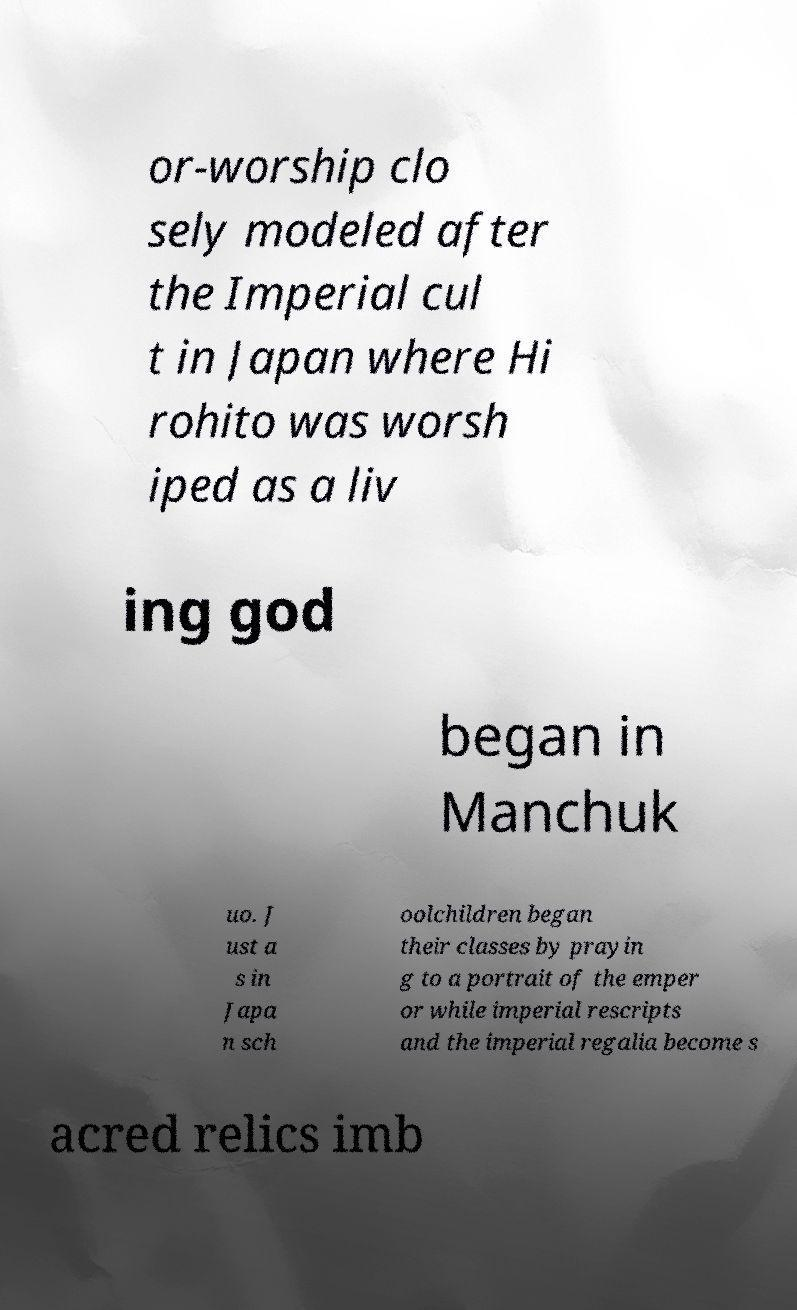Could you assist in decoding the text presented in this image and type it out clearly? or-worship clo sely modeled after the Imperial cul t in Japan where Hi rohito was worsh iped as a liv ing god began in Manchuk uo. J ust a s in Japa n sch oolchildren began their classes by prayin g to a portrait of the emper or while imperial rescripts and the imperial regalia become s acred relics imb 